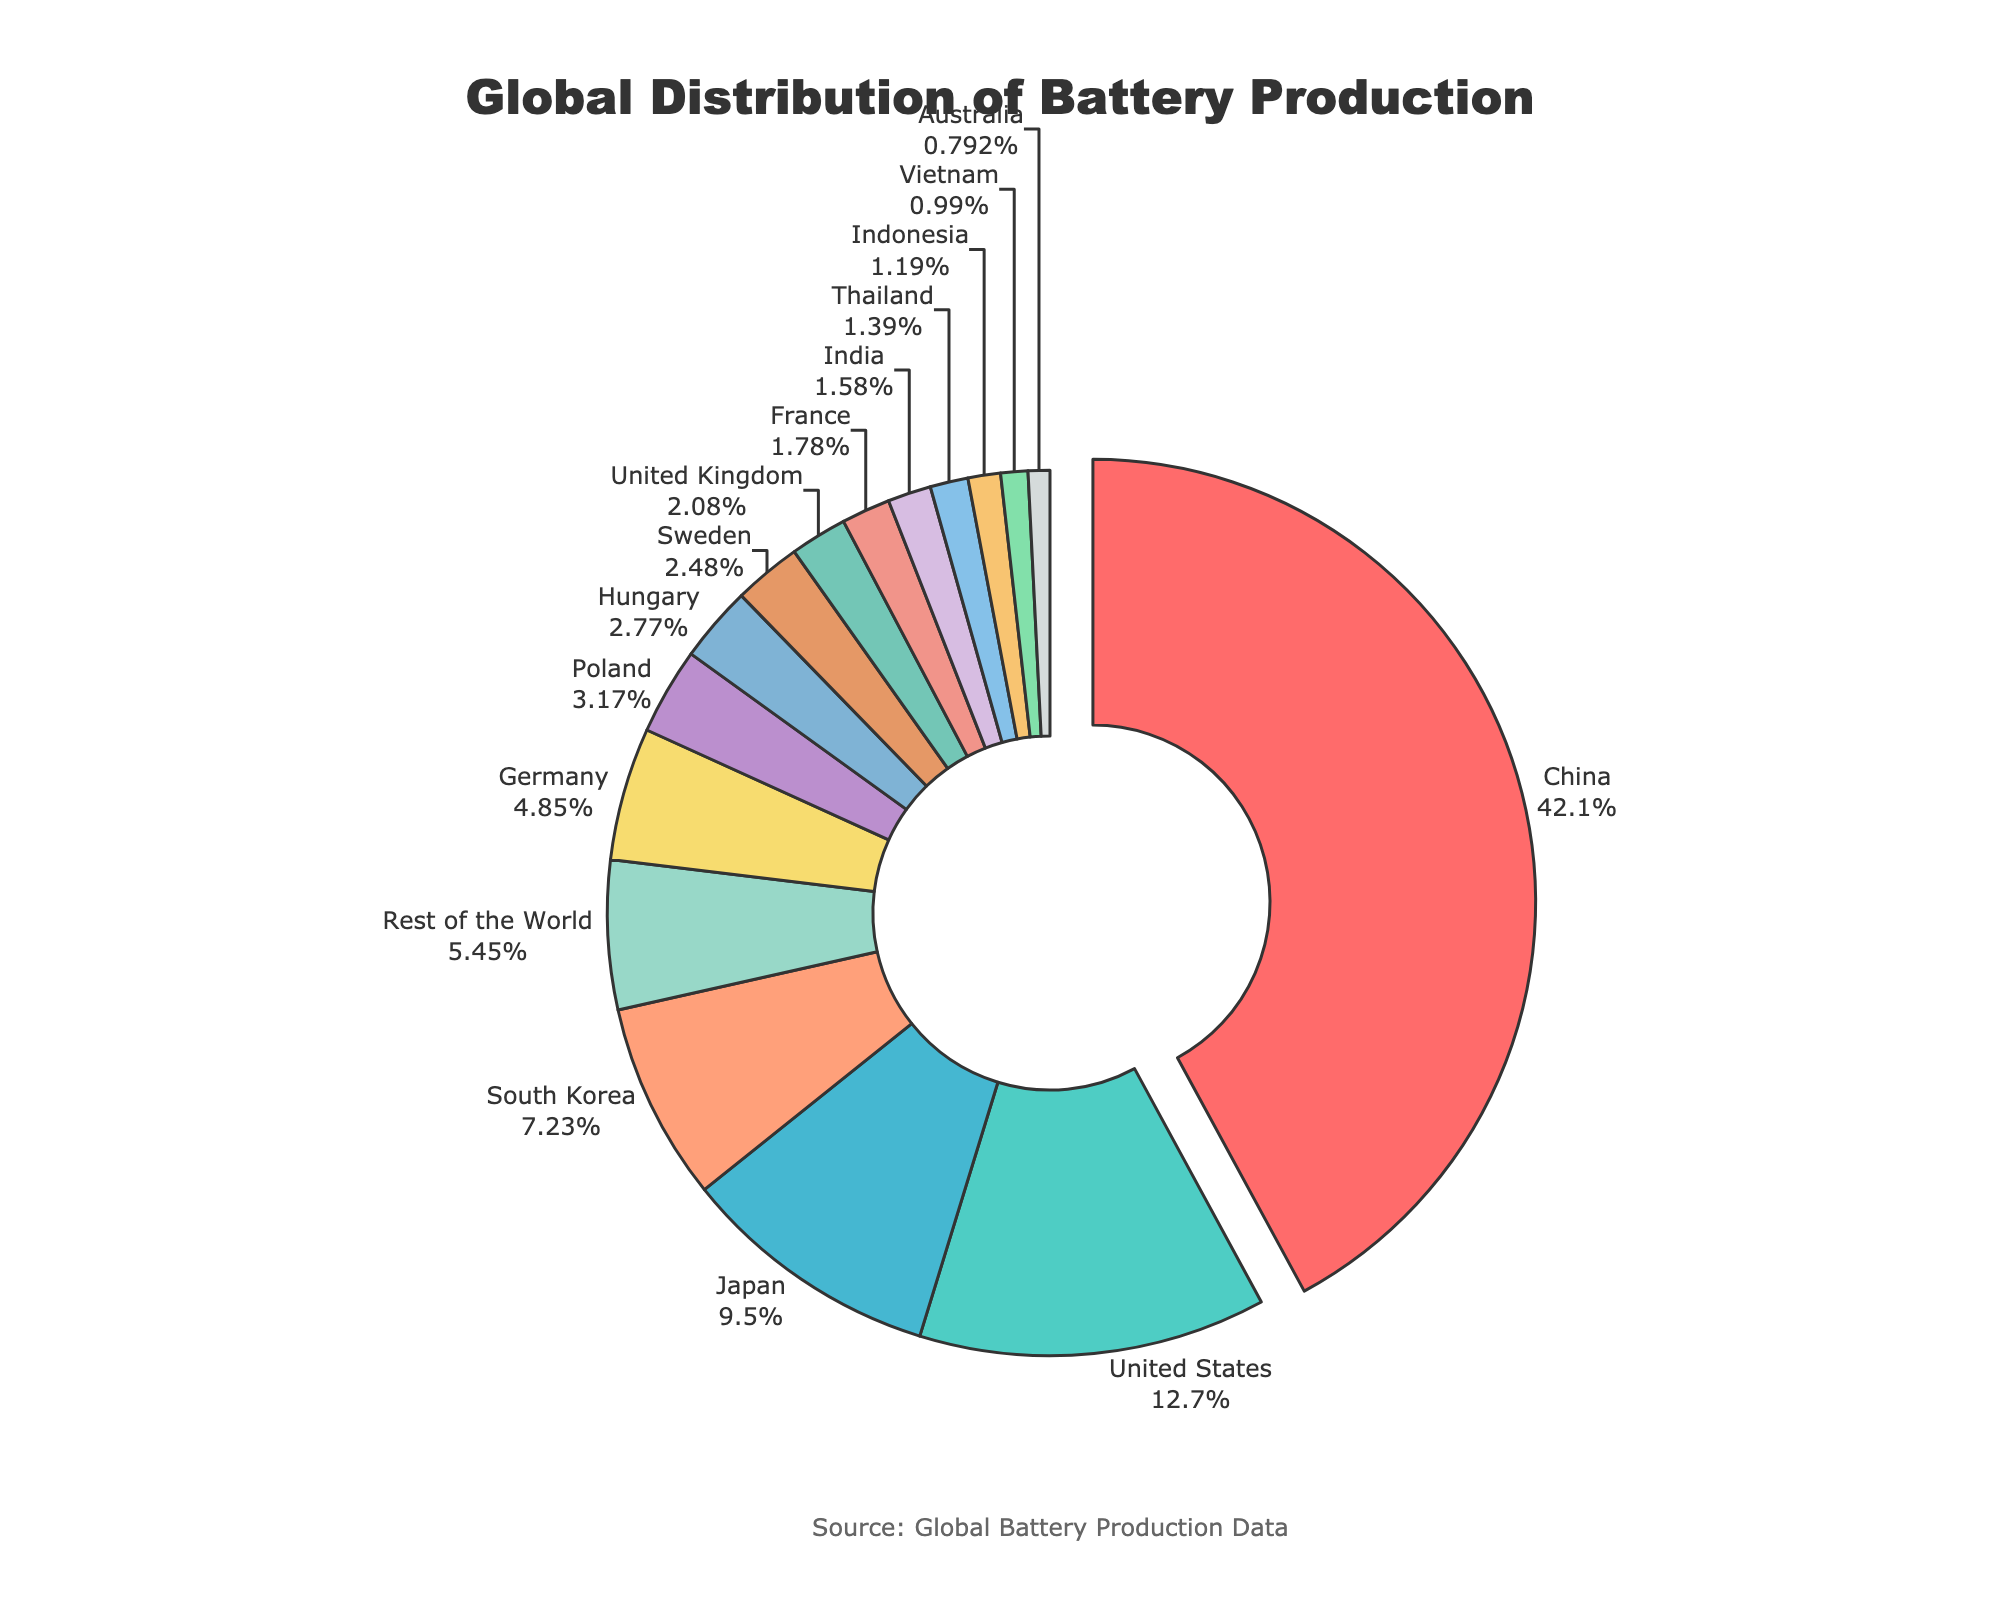What percentage of global battery production is accounted for by the top two countries combined? To find the combined percentage, simply add the percentages of China and the United States. China accounts for 42.5% and the United States accounts for 12.8%. So, 42.5 + 12.8 = 55.3%.
Answer: 55.3% Which country has a larger share of battery production, Germany or Japan, and by how much? Compare the percentages of Germany and Japan. Germany has 4.9% while Japan has 9.6%. To find the difference, subtract Germany's percentage from Japan's: 9.6 - 4.9 = 4.7%.
Answer: Japan by 4.7% How does South Korea's battery production compare to that of Poland and Hungary combined? First, add the percentages of Poland and Hungary: 3.2 + 2.8 = 6%. Now compare this with South Korea's percentage, which is 7.3%. South Korea has a higher percentage as 7.3 is greater than 6.
Answer: South Korea has greater percentage What is the average percentage of battery production for the bottom five countries collectively? Identify the percentages for the bottom five countries: Thailand (1.4%), Indonesia (1.2%), Vietnam (1.0%), Australia (0.8%), and Rest of the World (5.5%). Sum them: 1.4 + 1.2 + 1.0 + 0.8 + 5.5 = 9.9%. Now, divide by 5: 9.9 / 5 = 1.98%.
Answer: 1.98% Which country contributes more to global battery production, the United Kingdom or India, and by what percentage? Compare the percentages of the United Kingdom (2.1%) and India (1.6%). To find the difference: 2.1 - 1.6 = 0.5%.
Answer: United Kingdom by 0.5% What is the total percentage of battery production accounted for by Asian countries from the provided list? Identify the percentages for all Asian countries: China (42.5%), Japan (9.6%), South Korea (7.3%), India (1.6%), Thailand (1.4%), Indonesia (1.2%), and Vietnam (1.0%). Sum them: 42.5 + 9.6 + 7.3 + 1.6 + 1.4 + 1.2 + 1.0 = 64.6%.
Answer: 64.6% Which color represents Poland in the pie chart, and what does the slice indicate percentage-wise? Poland is represented in green shade in the pie chart, based on the color palette. The slice indicates 3.2% of the global battery production.
Answer: Green, 3.2% What visual characteristic distinguishes the segment representing China from other segments? China's segment is distinguished by being slightly pulled out from the pie chart, making it visually prominent.
Answer: Pulled out segment 